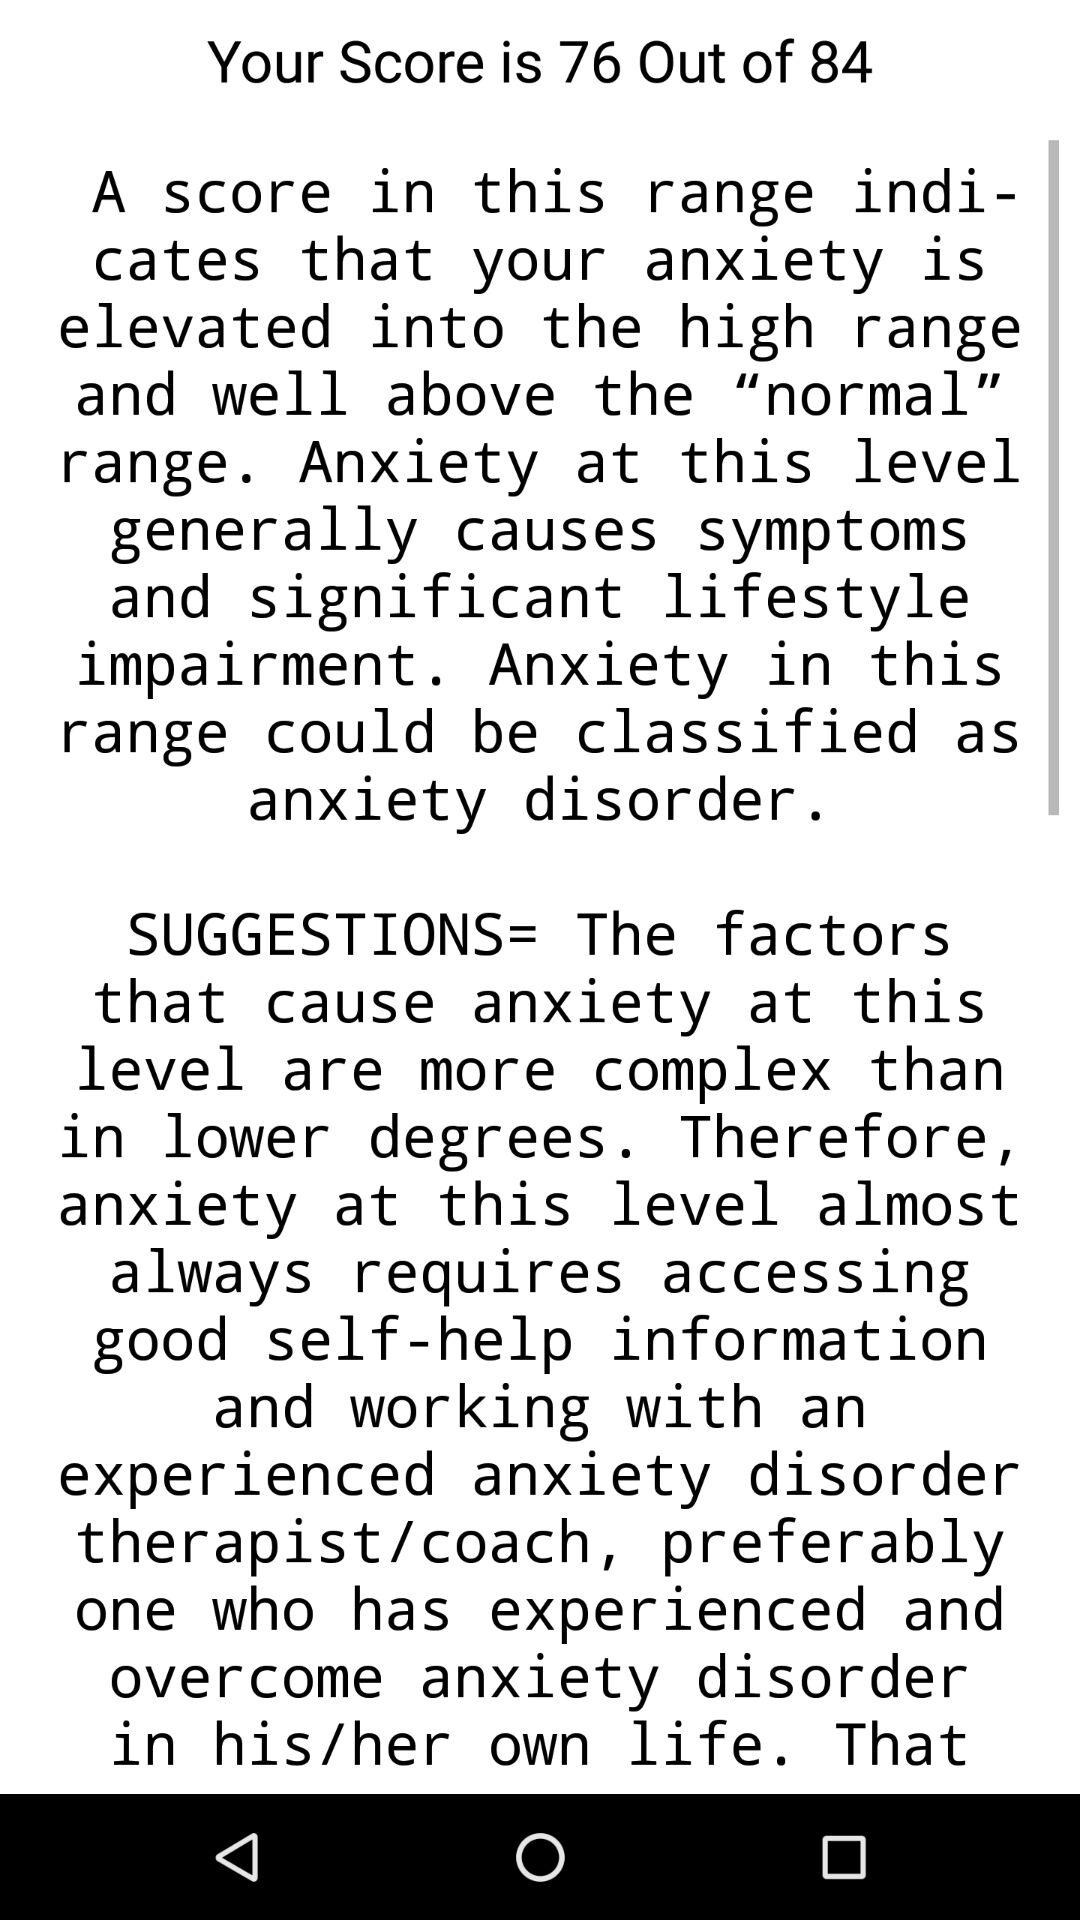What is the difference between the maximum score and the score shown?
Answer the question using a single word or phrase. 8 